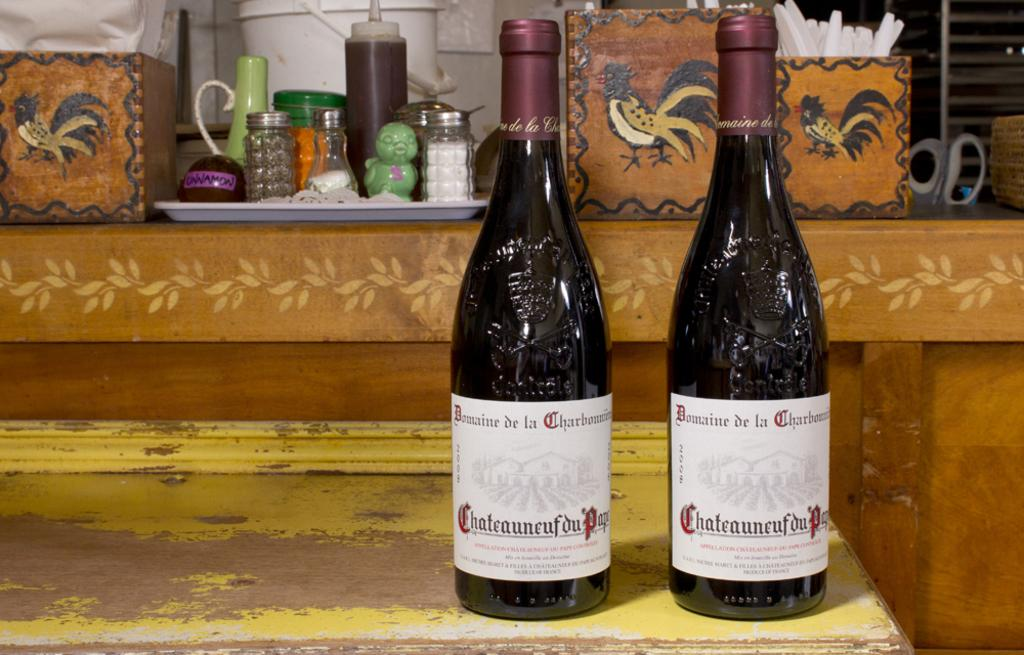<image>
Provide a brief description of the given image. Two bottles have the word Domaine on them. 